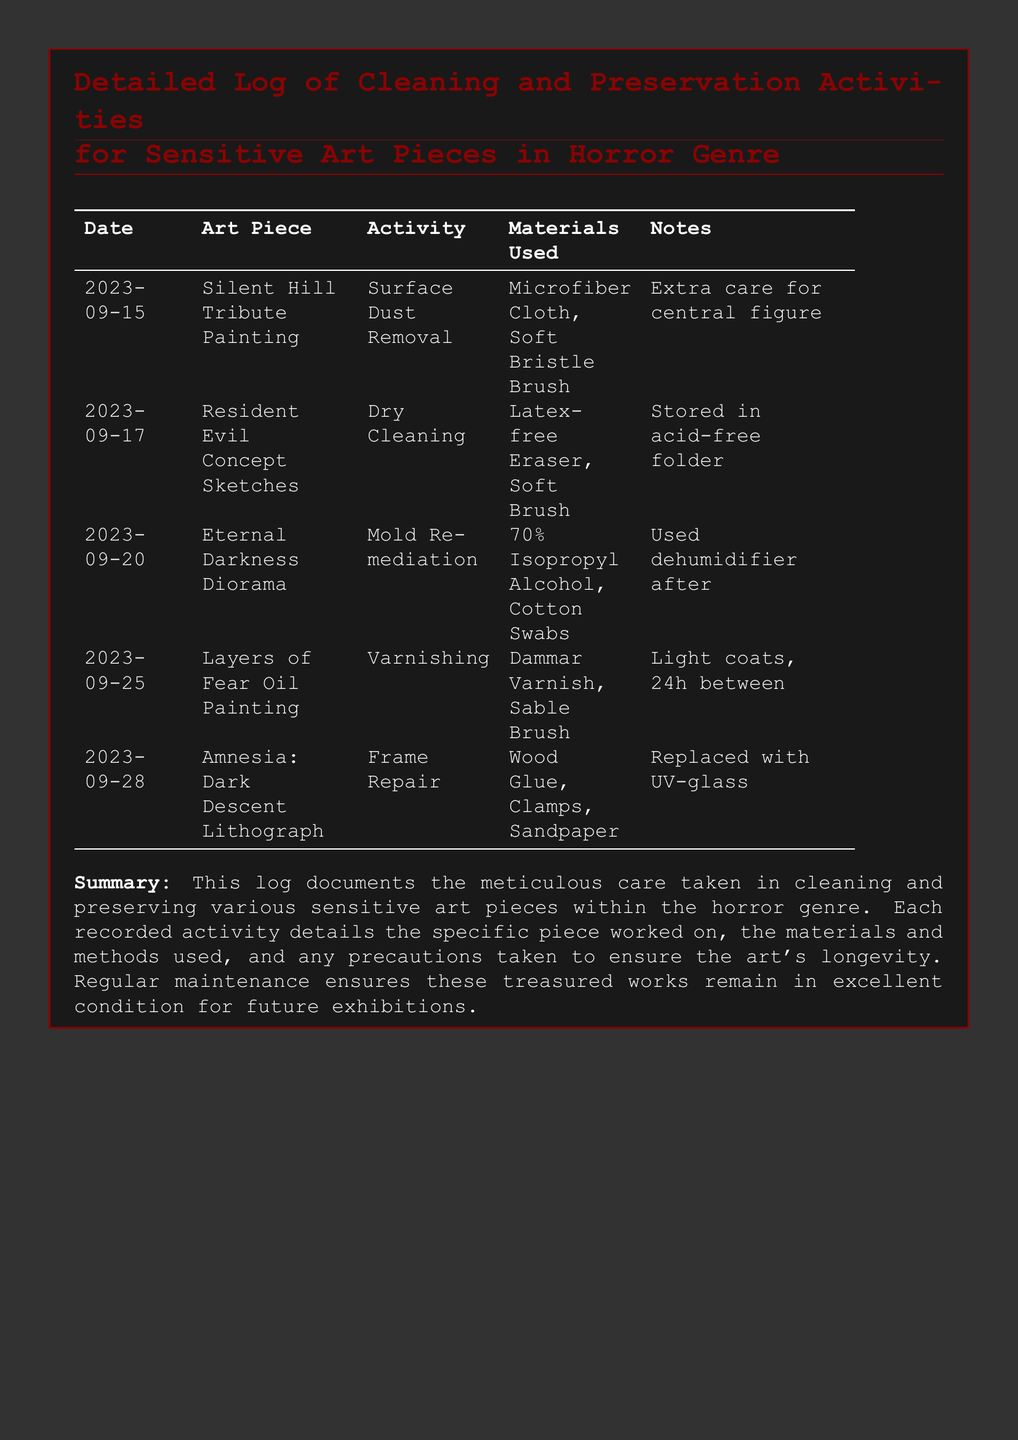What is the date of cleaning for the Eternal Darkness Diorama? The log lists the date when the cleaning activity for the Eternal Darkness Diorama was conducted, which is 2023-09-20.
Answer: 2023-09-20 What materials were used for the Surface Dust Removal? The document specifies that for Surface Dust Removal, a Microfiber Cloth and Soft Bristle Brush were used.
Answer: Microfiber Cloth, Soft Bristle Brush Which art piece had mold remediation performed on it? The log indicates that the Eternal Darkness Diorama underwent mold remediation.
Answer: Eternal Darkness Diorama How many days were between the varnishing coats for the Layers of Fear Oil Painting? The log states to allow 24 hours between each light coat of varnish for the Layers of Fear Oil Painting.
Answer: 24h What type of varnish was used for the Layers of Fear Oil Painting? The document specifies that Dammar Varnish was used for varnishing.
Answer: Dammar Varnish What was replaced with UV-glass during the frame repair? The log details that the frame for the Amnesia: Dark Descent Lithograph was updated with UV-glass.
Answer: Amnesia: Dark Descent Lithograph How many art pieces are documented in this log? The log contains entries for five different art pieces, as shown in the table.
Answer: 5 What cleaning method was used for the Resident Evil Concept Sketches? The log indicates that Dry Cleaning was performed on the Resident Evil Concept Sketches.
Answer: Dry Cleaning What additional equipment was used after mold remediation? The document mentions that a dehumidifier was used following mold remediation.
Answer: Dehumidifier 